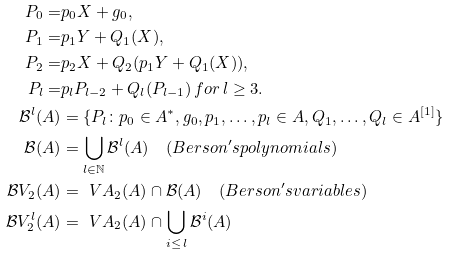<formula> <loc_0><loc_0><loc_500><loc_500>P _ { 0 } = & p _ { 0 } X + g _ { 0 } , \\ P _ { 1 } = & p _ { 1 } Y + Q _ { 1 } ( X ) , \\ P _ { 2 } = & p _ { 2 } X + Q _ { 2 } ( p _ { 1 } Y + Q _ { 1 } ( X ) ) , \\ P _ { l } = & p _ { l } P _ { l - 2 } + Q _ { l } ( P _ { l - 1 } ) \, f o r \, l \geq 3 . \\ \mathcal { B } ^ { l } ( A ) & = \{ P _ { l } \colon p _ { 0 } \in A ^ { * } , g _ { 0 } , p _ { 1 } , \dots , p _ { l } \in A , Q _ { 1 } , \dots , Q _ { l } \in A ^ { [ 1 ] } \} \\ \mathcal { B } ( A ) & = \bigcup _ { l \in \mathbb { N } } \mathcal { B } ^ { l } ( A ) \quad ( B e r s o n ^ { \prime } s p o l y n o m i a l s ) \\ \mathcal { B } V _ { 2 } ( A ) & = { \ V A } _ { 2 } ( A ) \cap \mathcal { B } ( A ) \quad ( B e r s o n ^ { \prime } s v a r i a b l e s ) \\ \mathcal { B } V _ { 2 } ^ { l } ( A ) & = { \ V A } _ { 2 } ( A ) \cap \bigcup _ { i \leq \, l } \mathcal { B } ^ { i } ( A ) \\</formula> 